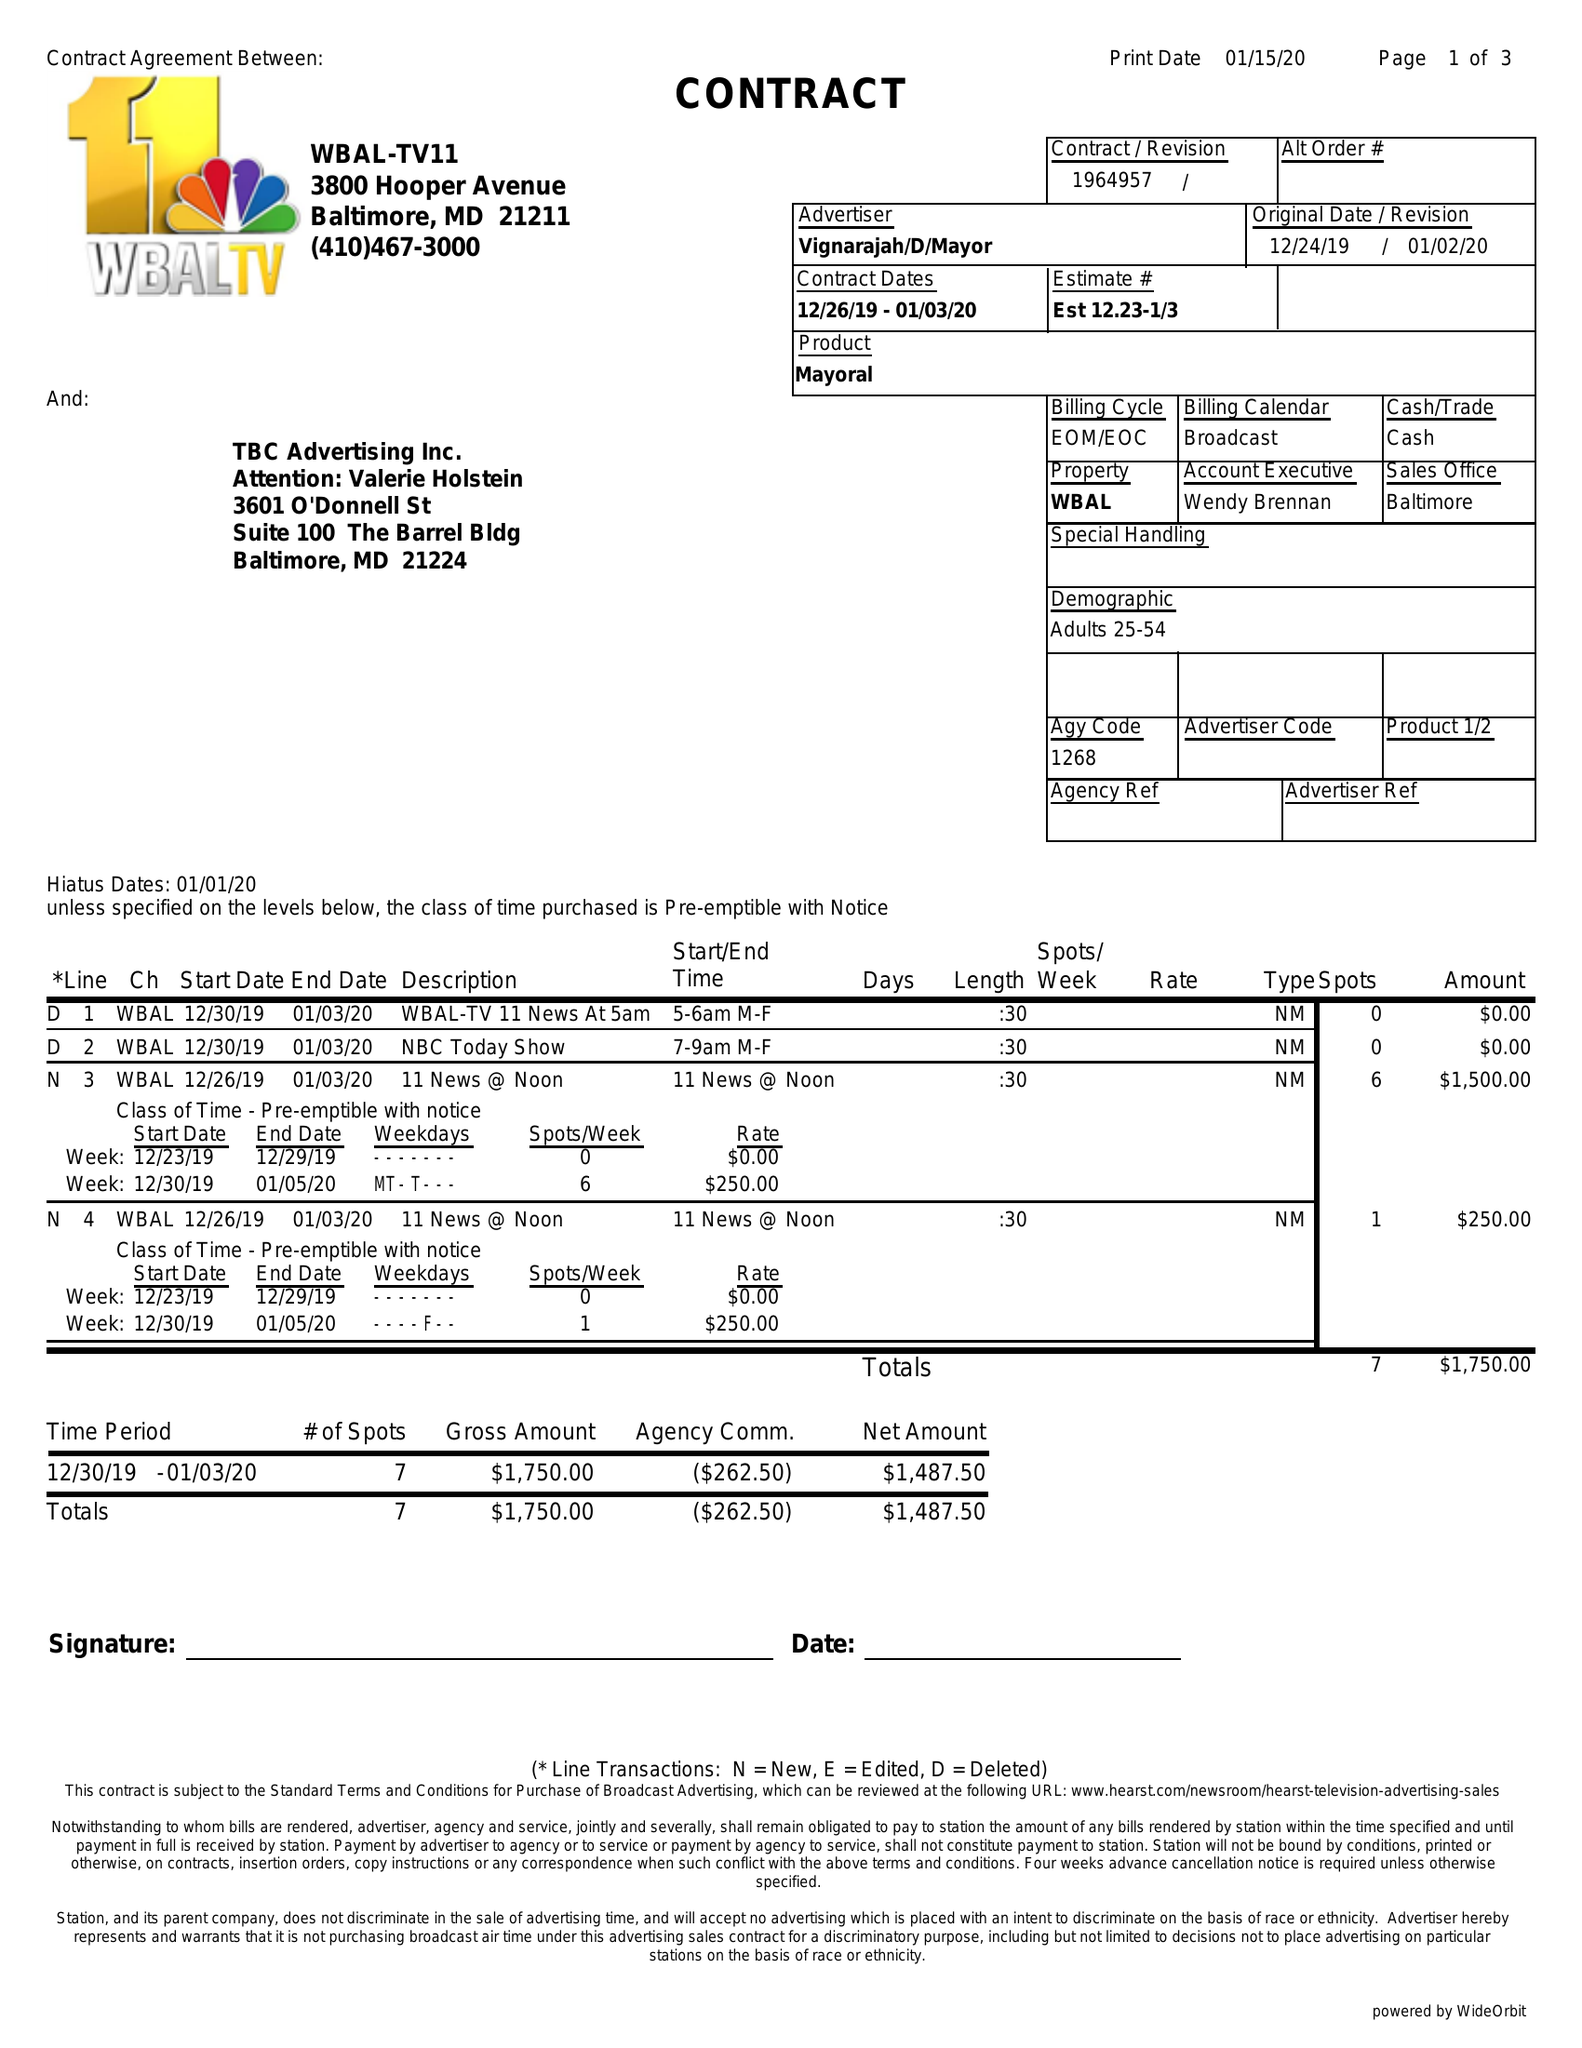What is the value for the flight_to?
Answer the question using a single word or phrase. 01/03/20 